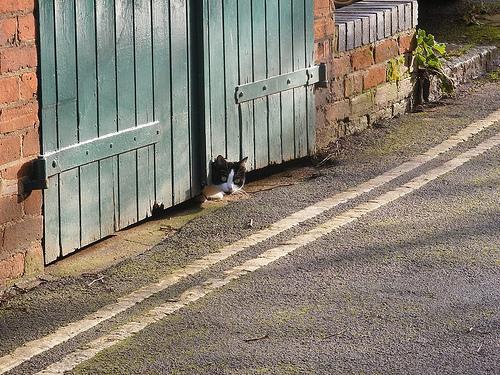How many animals are in the picture?
Write a very short answer. 1. Is the cat a stray?
Quick response, please. Yes. Is the cat sleeping?
Answer briefly. No. 